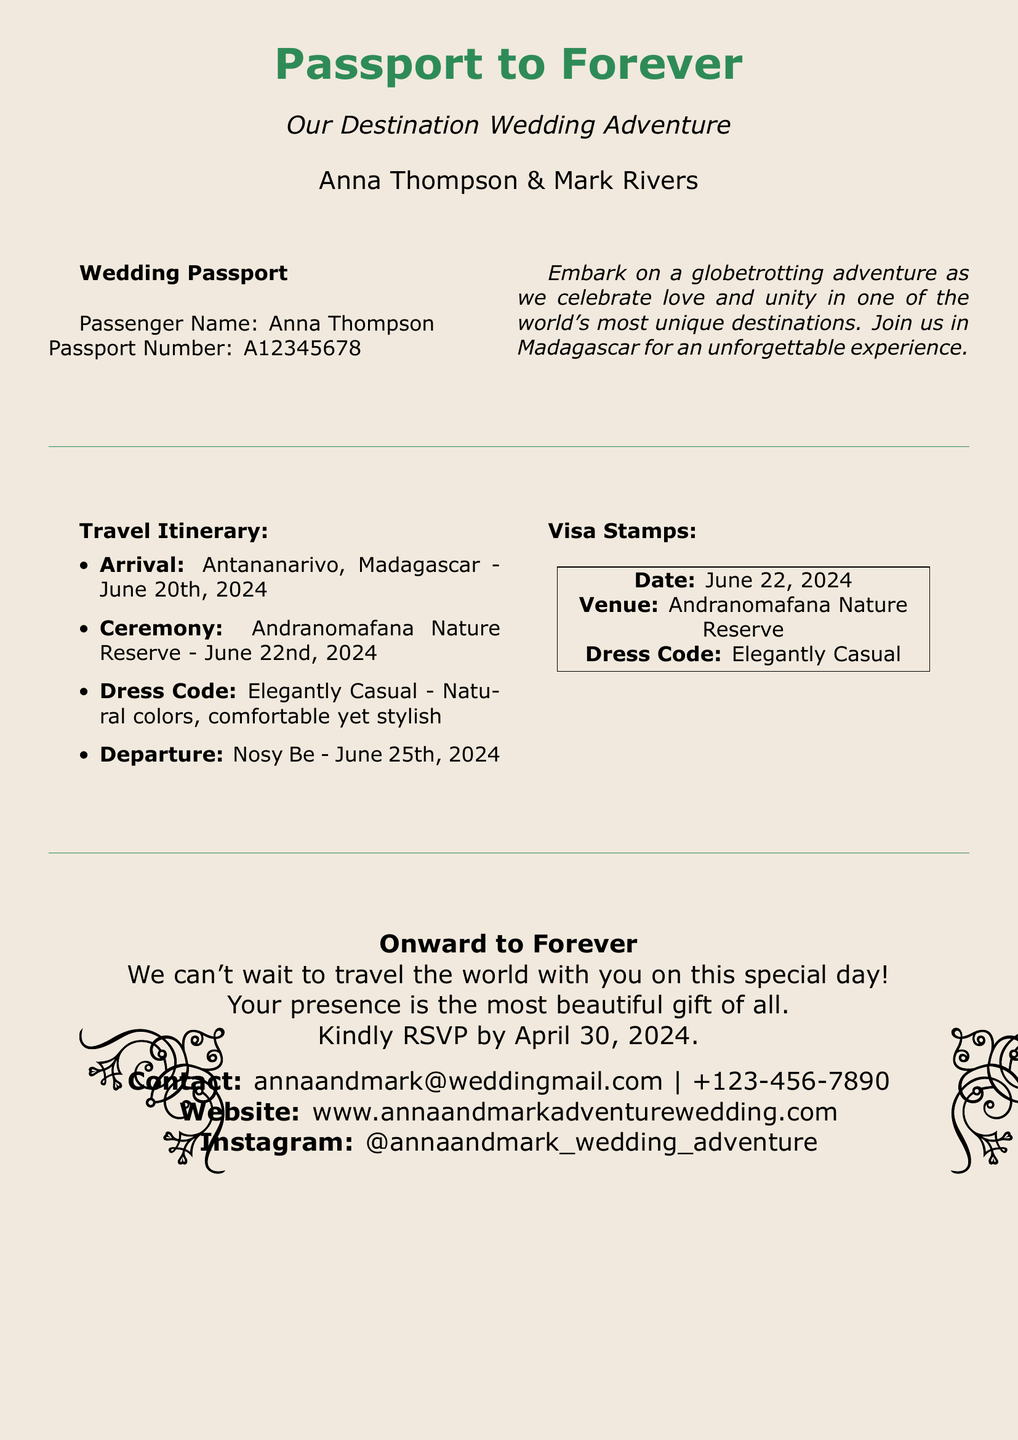What is the couple's names? The couples' names are stated in the invitation text, which includes Anna Thompson and Mark Rivers.
Answer: Anna Thompson & Mark Rivers When is the wedding ceremony date? The date of the wedding ceremony is explicitly mentioned in the travel itinerary section of the document.
Answer: June 22nd, 2024 Where is the wedding ceremony taking place? The venue for the ceremony is indicated in the travel itinerary as Andranomafana Nature Reserve.
Answer: Andranomafana Nature Reserve What is the dress code for the wedding? The dress code is described in the travel itinerary, specifying the attire expected for the guests.
Answer: Elegantly Casual On what date should guests RSVP by? The RSVP date is provided at the bottom of the document as the deadline for guests to confirm their attendance.
Answer: April 30, 2024 What is the primary theme of the invitation? The theme can be inferred from the title of the invitation, which reflects a travel motif related to the wedding.
Answer: Destination Wedding Adventure Which city are guests arriving at? The arrival city is given in the travel itinerary as the starting point for the wedding adventure.
Answer: Antananarivo What unique feature does this wedding invitation have? The invitation's design mimics a passport, enhancing the travel theme associated with the wedding event.
Answer: Customized passport 